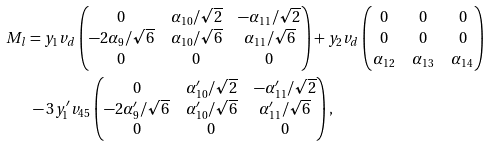<formula> <loc_0><loc_0><loc_500><loc_500>M _ { l } & = y _ { 1 } v _ { d } \begin{pmatrix} 0 & \alpha _ { 1 0 } / \sqrt { 2 } & - \alpha _ { 1 1 } / \sqrt { 2 } \\ - 2 \alpha _ { 9 } / \sqrt { 6 } & \alpha _ { 1 0 } / \sqrt { 6 } & \alpha _ { 1 1 } / \sqrt { 6 } \\ 0 & 0 & 0 \end{pmatrix} + y _ { 2 } v _ { d } \begin{pmatrix} 0 & 0 & 0 \\ 0 & 0 & 0 \\ \alpha _ { 1 2 } & \alpha _ { 1 3 } & \alpha _ { 1 4 } \end{pmatrix} \\ & \ - 3 y _ { 1 } ^ { \prime } v _ { 4 5 } \begin{pmatrix} 0 & \alpha _ { 1 0 } ^ { \prime } / \sqrt { 2 } & - \alpha _ { 1 1 } ^ { \prime } / \sqrt { 2 } \\ - 2 \alpha _ { 9 } ^ { \prime } / \sqrt { 6 } & \alpha _ { 1 0 } ^ { \prime } / \sqrt { 6 } & \alpha _ { 1 1 } ^ { \prime } / \sqrt { 6 } \\ 0 & 0 & 0 \end{pmatrix} ,</formula> 